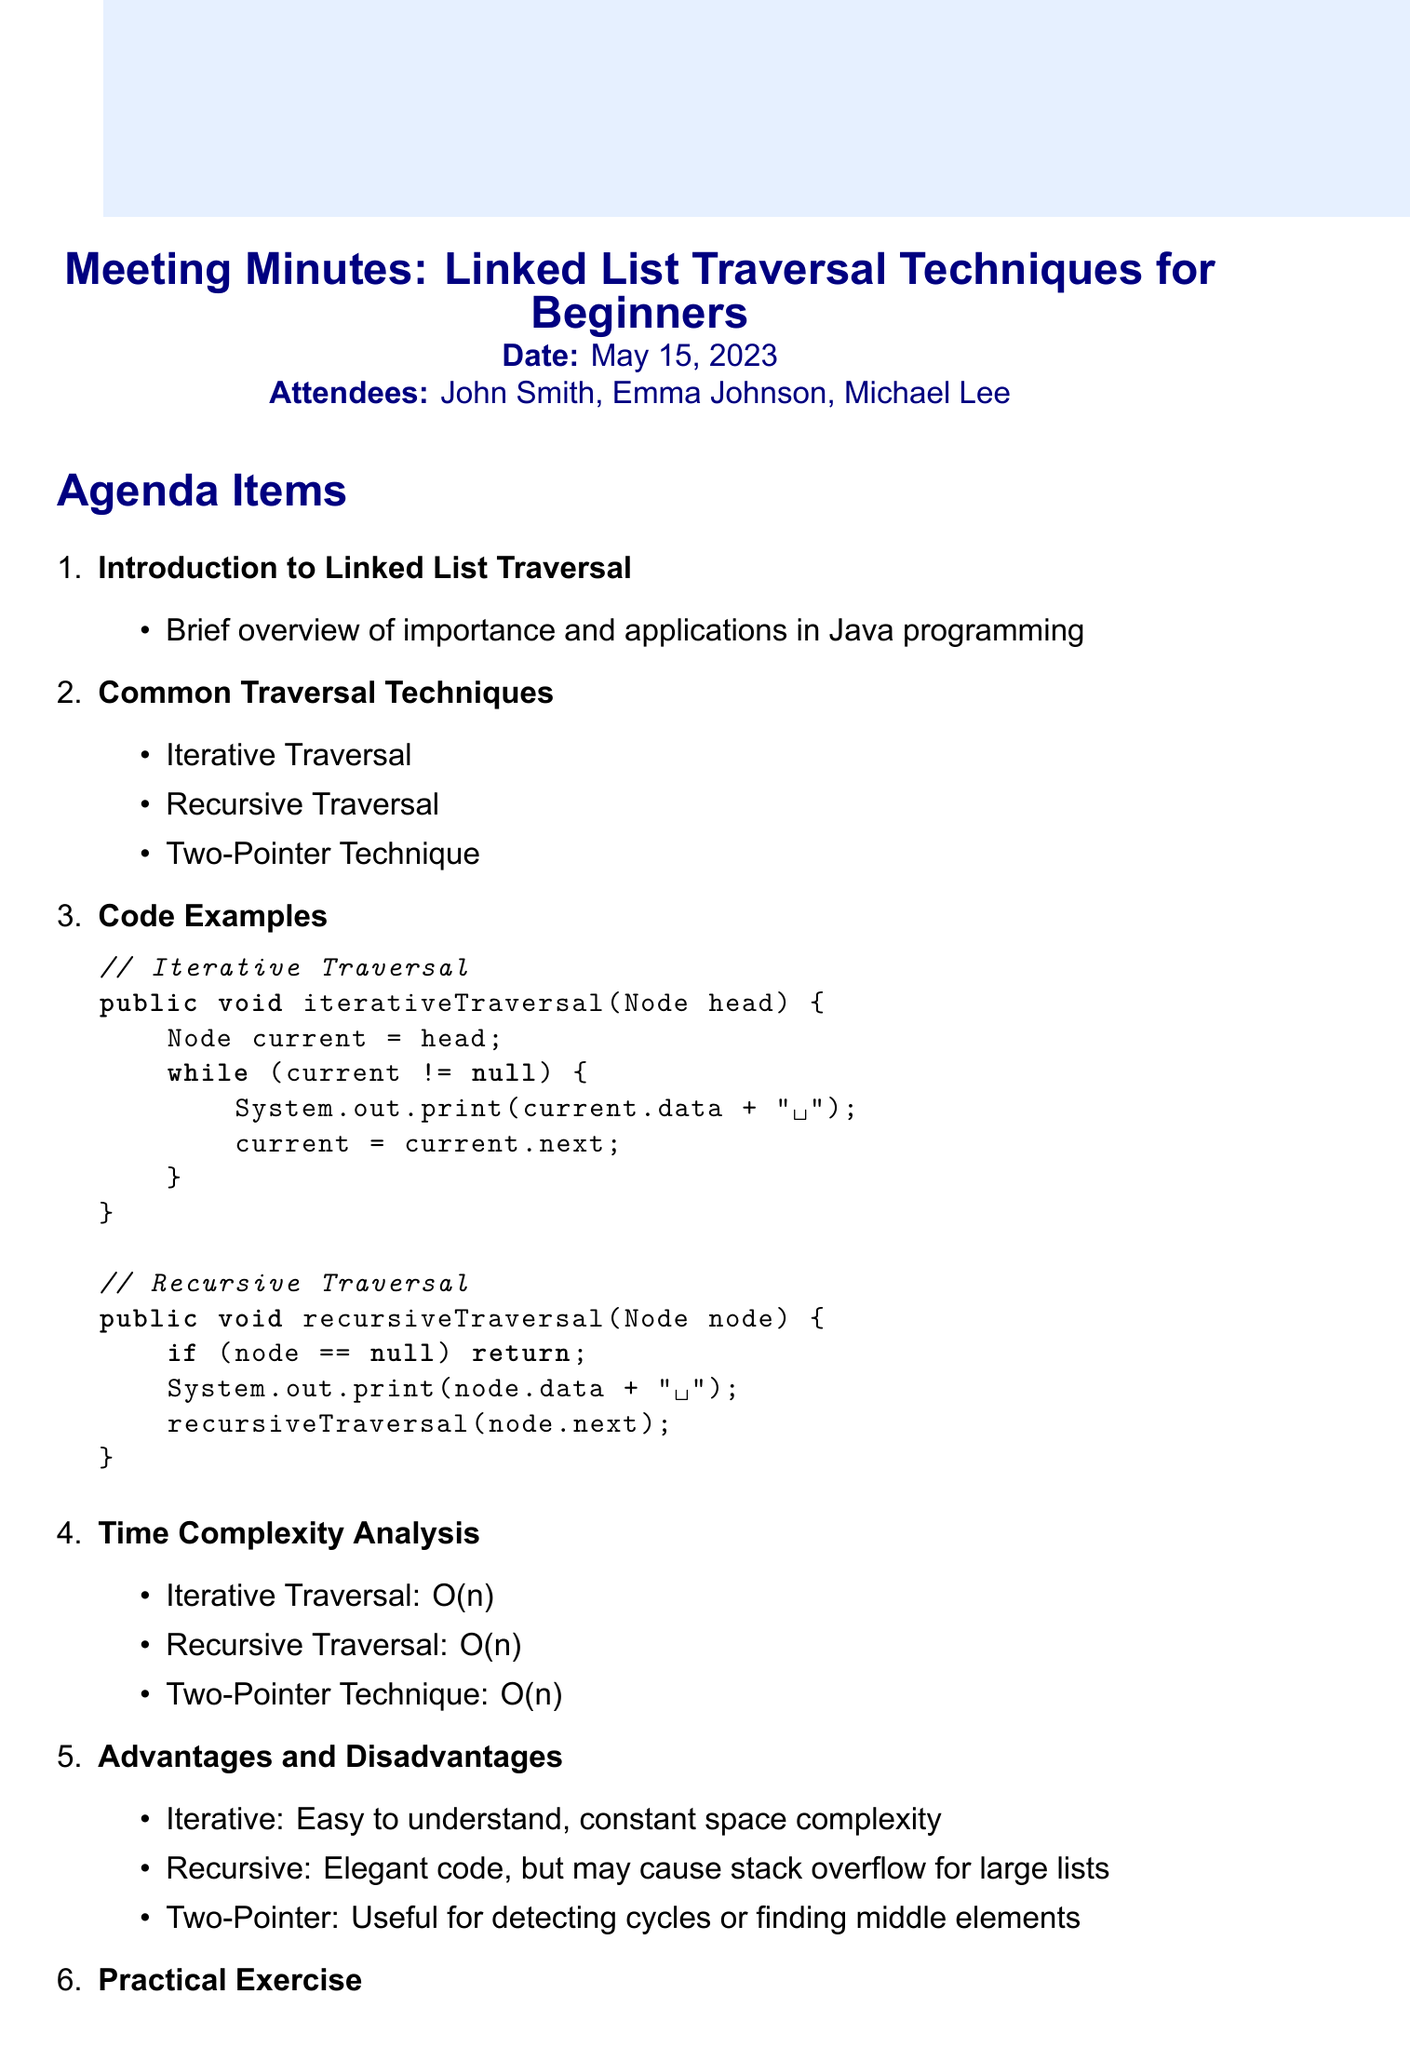What is the meeting title? The meeting title is specifically stated at the beginning of the document as "Linked List Traversal Techniques for Beginners."
Answer: Linked List Traversal Techniques for Beginners On what date was the meeting held? The date of the meeting is clearly mentioned in the document as May 15, 2023.
Answer: May 15, 2023 Who is one of the attendees? Attendees are listed in the document, and one of them is John Smith.
Answer: John Smith What is the time complexity of the iterative traversal technique? The document provides the time complexity analysis, stating that the iterative traversal has a complexity of O(n).
Answer: O(n) What is an advantage of the iterative traversal? The document mentions that one advantage of iterative traversal is that it is easy to understand.
Answer: Easy to understand Which technique is suggested for detecting cycles? The document indicates that the two-pointer technique is useful for detecting cycles in linked lists.
Answer: Two-Pointer Technique What practical exercise is mentioned in the meeting? The document states that the practical exercise involves implementing a method to find the middle element of a linked list.
Answer: Find the middle element of a linked list What is one resource listed for additional learning? The document includes several resources, one of which is the Java Documentation: java.util.LinkedList.
Answer: Java Documentation: java.util.LinkedList What is a disadvantage of the recursive traversal? The document notes that a disadvantage of recursive traversal is that it may cause stack overflow for large lists.
Answer: May cause stack overflow for large lists How many attendees were present at the meeting? The document lists three attendees, reflecting the total number present at the meeting.
Answer: Three 